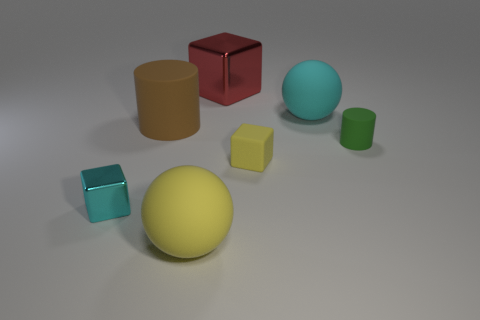The green thing that is made of the same material as the large yellow object is what shape?
Ensure brevity in your answer.  Cylinder. Do the tiny yellow rubber object and the cyan matte thing have the same shape?
Keep it short and to the point. No. The big metal block is what color?
Your answer should be very brief. Red. How many things are green cylinders or small metal things?
Your response must be concise. 2. Is there any other thing that has the same material as the large yellow sphere?
Offer a terse response. Yes. Is the number of red metallic objects that are left of the tiny shiny object less than the number of big cyan matte things?
Offer a terse response. Yes. Is the number of tiny rubber objects to the right of the small yellow cube greater than the number of large rubber things behind the big cyan rubber ball?
Give a very brief answer. Yes. Is there anything else of the same color as the big metal block?
Make the answer very short. No. What is the object that is in front of the cyan shiny object made of?
Keep it short and to the point. Rubber. Do the green thing and the cyan metal block have the same size?
Ensure brevity in your answer.  Yes. 